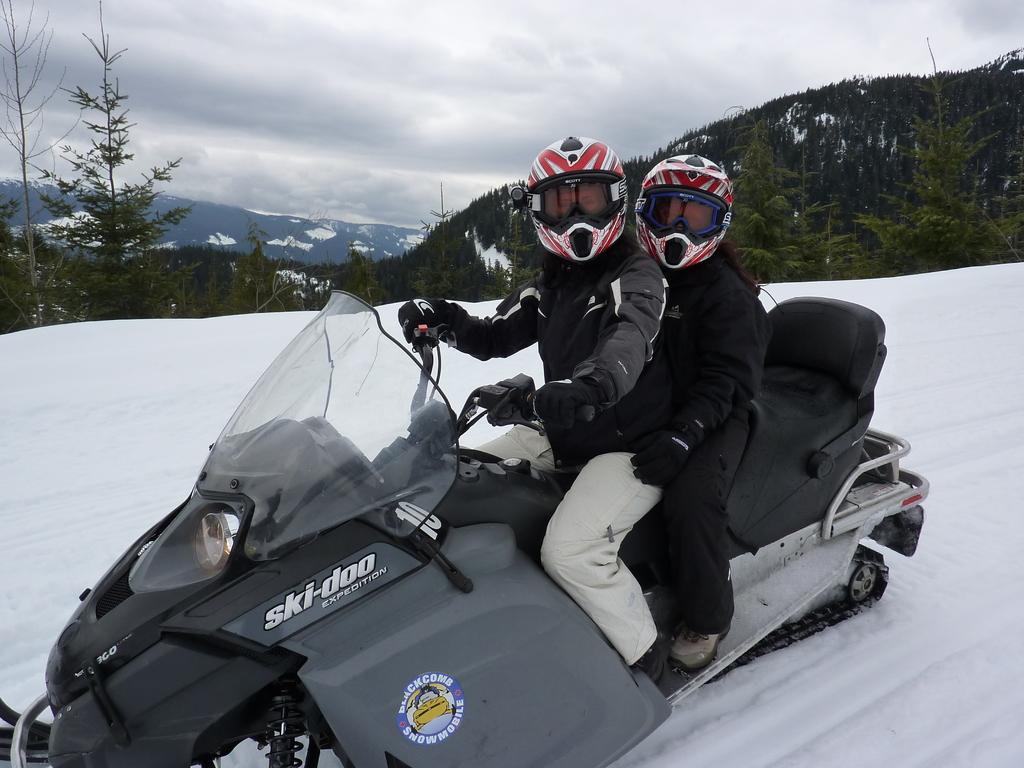In one or two sentences, can you explain what this image depicts? In this image we can see two persons wearing helmets sitting on a motorcycle which is on the ground covered with snow. On the backside we can see a group of trees, the ice hills and the sky which looks cloudy. 